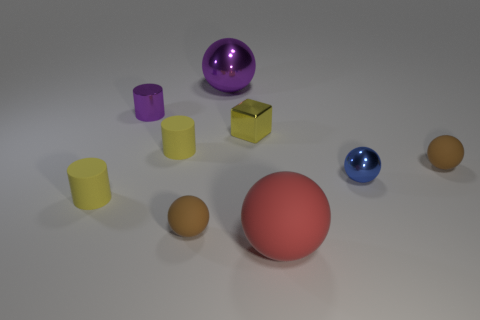Subtract all blue balls. How many balls are left? 4 Subtract all large purple spheres. How many spheres are left? 4 Subtract all yellow balls. Subtract all purple cylinders. How many balls are left? 5 Subtract all blocks. How many objects are left? 8 Subtract 1 red spheres. How many objects are left? 8 Subtract all tiny yellow metallic cubes. Subtract all small blue balls. How many objects are left? 7 Add 2 tiny blue metallic objects. How many tiny blue metallic objects are left? 3 Add 3 red metallic spheres. How many red metallic spheres exist? 3 